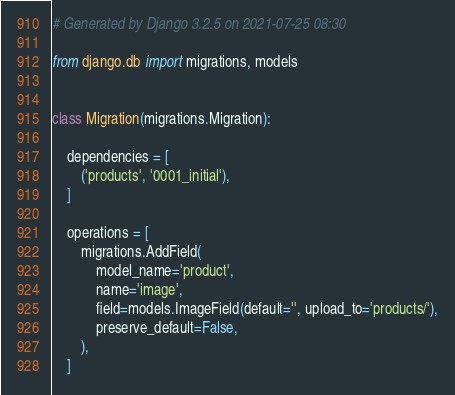Convert code to text. <code><loc_0><loc_0><loc_500><loc_500><_Python_># Generated by Django 3.2.5 on 2021-07-25 08:30

from django.db import migrations, models


class Migration(migrations.Migration):

    dependencies = [
        ('products', '0001_initial'),
    ]

    operations = [
        migrations.AddField(
            model_name='product',
            name='image',
            field=models.ImageField(default='', upload_to='products/'),
            preserve_default=False,
        ),
    ]
</code> 